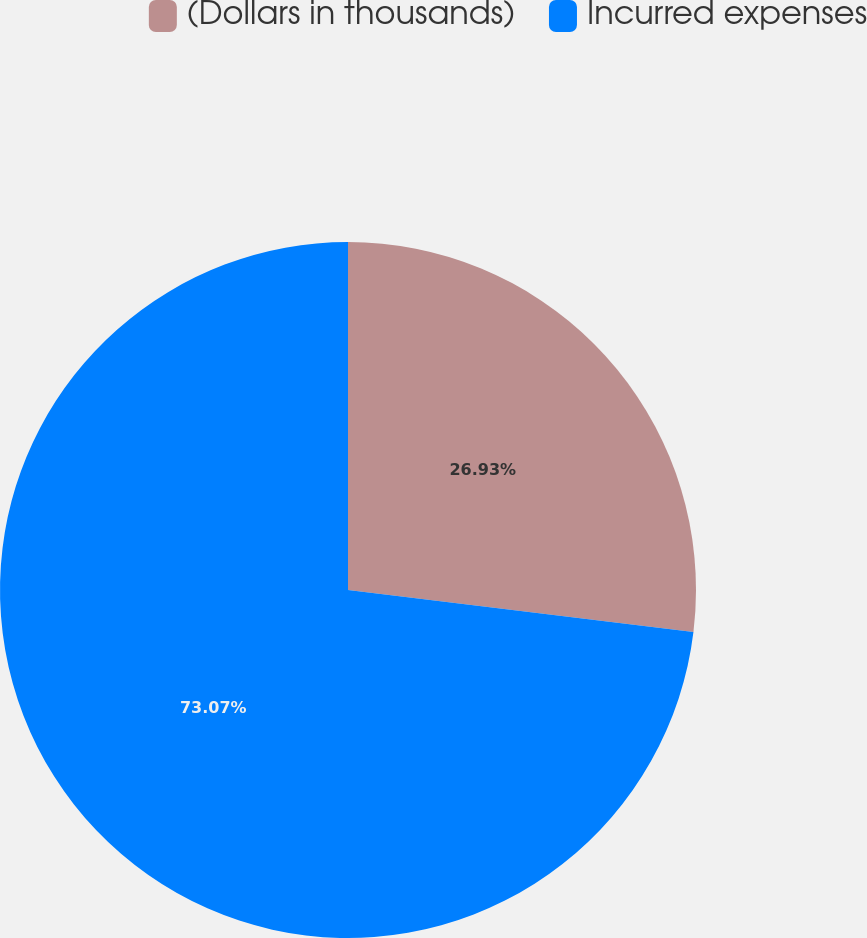<chart> <loc_0><loc_0><loc_500><loc_500><pie_chart><fcel>(Dollars in thousands)<fcel>Incurred expenses<nl><fcel>26.93%<fcel>73.07%<nl></chart> 